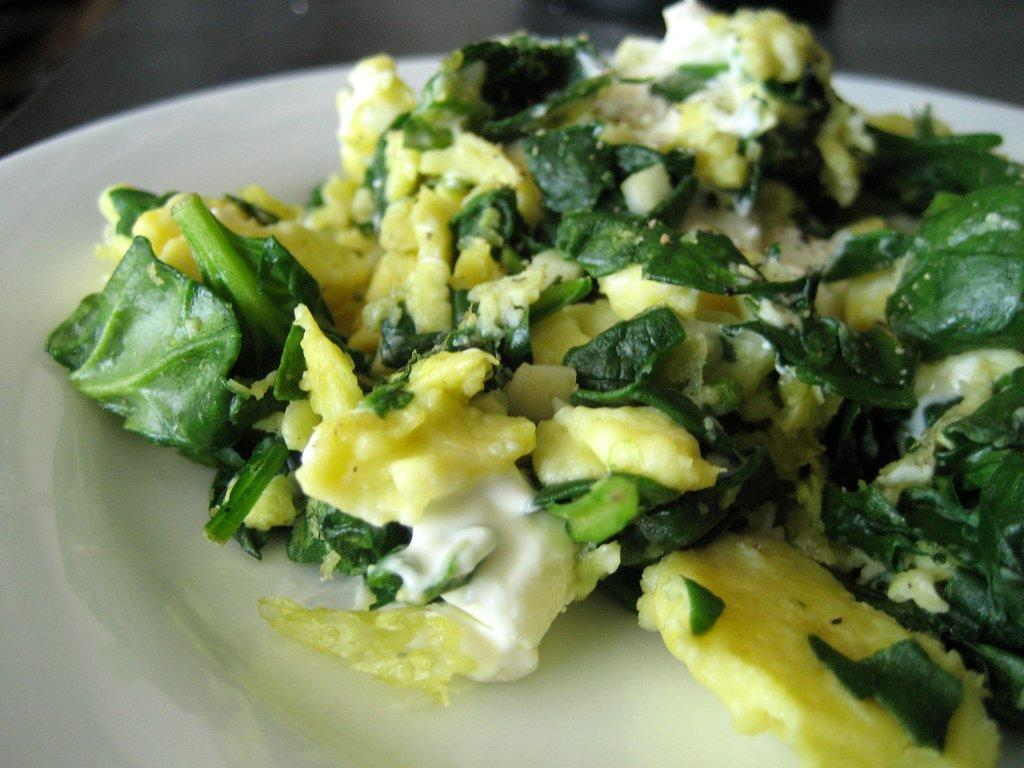What is the main subject in the image? There is a food item in the image. How is the food item presented in the image? The food item is in a plate. Where is the plate with the food item located? The plate with the food item is placed on a table. What type of system is the food item using to quiver in the image? The food item is not quivering in the image, and there is no system present. How many legs can be seen supporting the table in the image? The image does not show the legs of the table, so it cannot be determined from the image. 